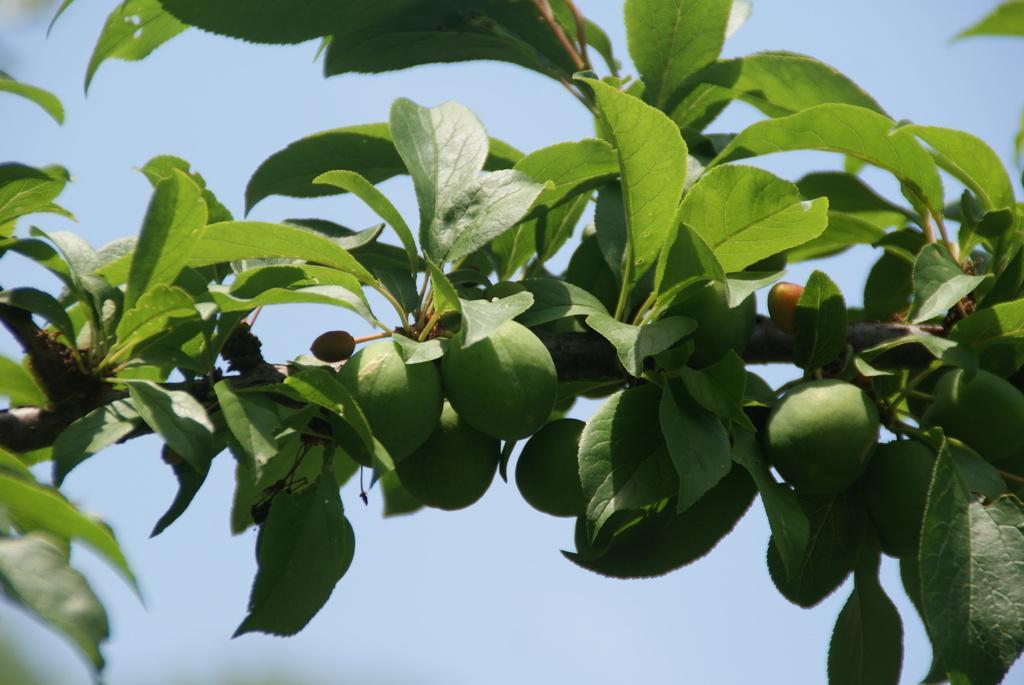In one or two sentences, can you explain what this image depicts? In this image there is a branch of a tree, for that branch there are leaves and fruits, in the background there is the sky. 